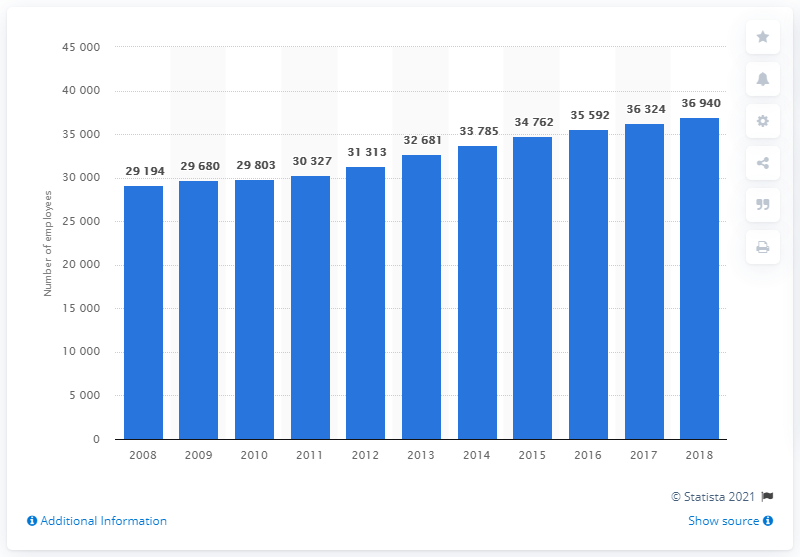Highlight a few significant elements in this photo. In 2018, there were approximately 36,940 physicians employed in the healthcare sector in Switzerland. 